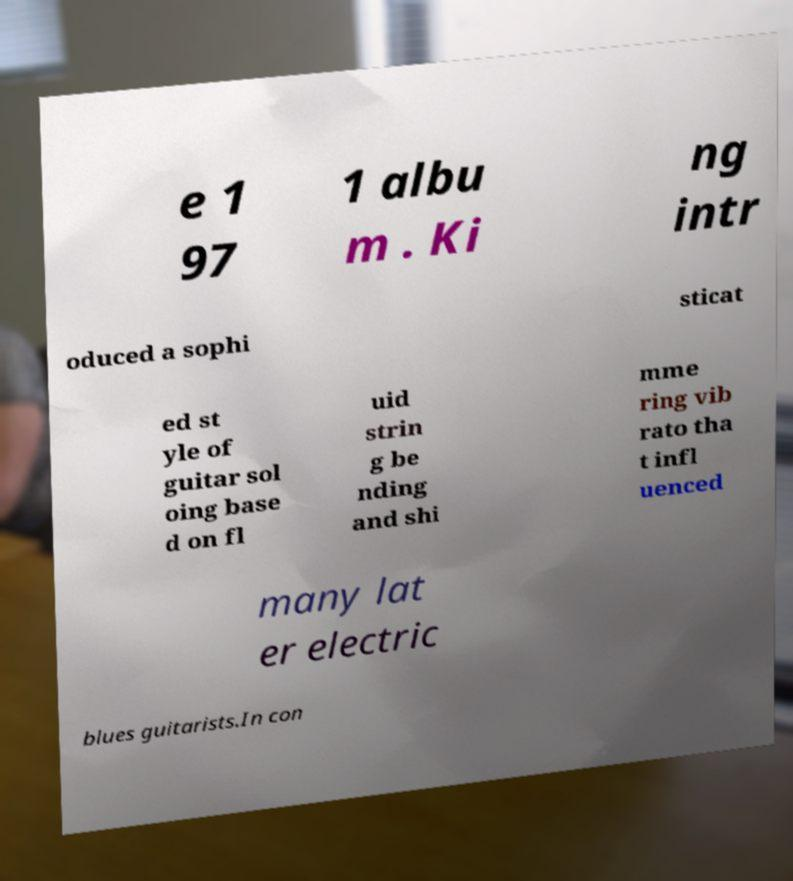What messages or text are displayed in this image? I need them in a readable, typed format. e 1 97 1 albu m . Ki ng intr oduced a sophi sticat ed st yle of guitar sol oing base d on fl uid strin g be nding and shi mme ring vib rato tha t infl uenced many lat er electric blues guitarists.In con 